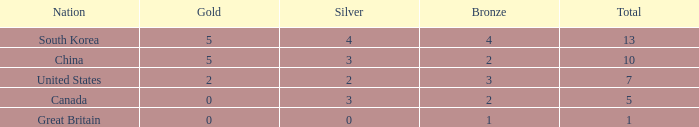What is the minimum amount of gold for canada when the rank is above 4? None. 